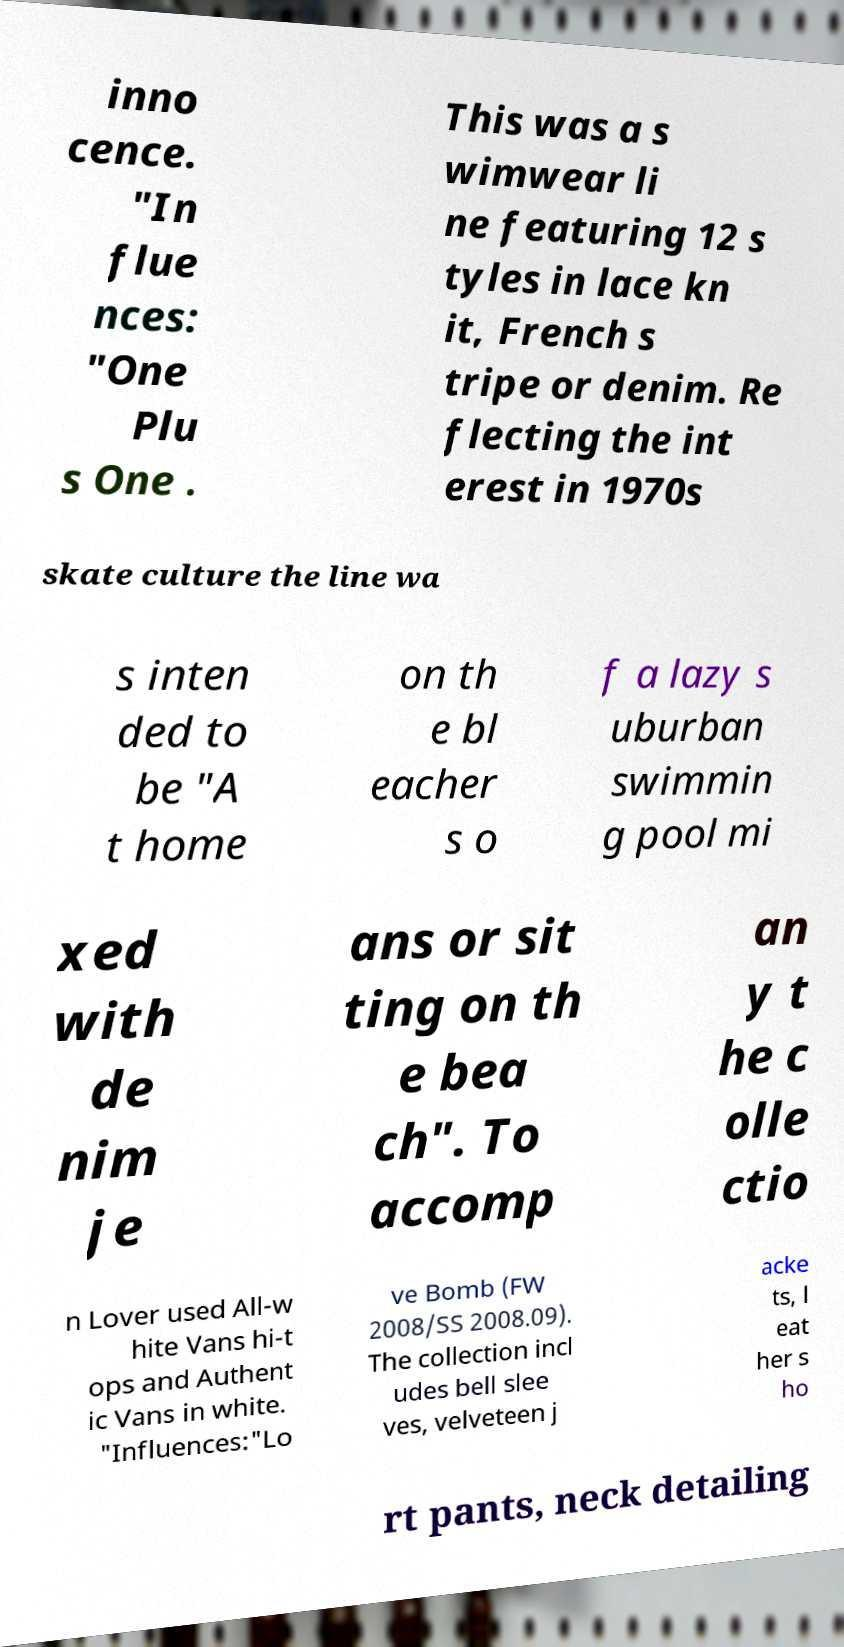I need the written content from this picture converted into text. Can you do that? inno cence. "In flue nces: "One Plu s One . This was a s wimwear li ne featuring 12 s tyles in lace kn it, French s tripe or denim. Re flecting the int erest in 1970s skate culture the line wa s inten ded to be "A t home on th e bl eacher s o f a lazy s uburban swimmin g pool mi xed with de nim je ans or sit ting on th e bea ch". To accomp an y t he c olle ctio n Lover used All-w hite Vans hi-t ops and Authent ic Vans in white. "Influences:"Lo ve Bomb (FW 2008/SS 2008.09). The collection incl udes bell slee ves, velveteen j acke ts, l eat her s ho rt pants, neck detailing 